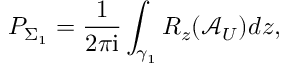<formula> <loc_0><loc_0><loc_500><loc_500>P _ { \Sigma _ { 1 } } = \frac { 1 } { 2 \pi i } \int _ { \gamma _ { 1 } } R _ { z } ( \mathcal { A } _ { U } ) d z ,</formula> 